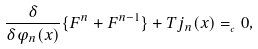Convert formula to latex. <formula><loc_0><loc_0><loc_500><loc_500>\frac { \delta } { \delta \varphi _ { n } ( x ) } \{ F ^ { n } + F ^ { n - 1 } \} + T j _ { n } ( x ) = _ { _ { c } } 0 ,</formula> 